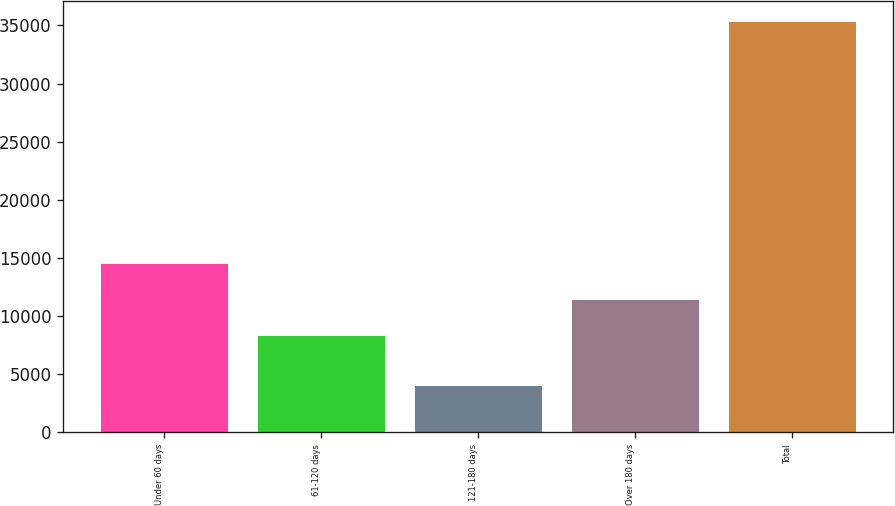<chart> <loc_0><loc_0><loc_500><loc_500><bar_chart><fcel>Under 60 days<fcel>61-120 days<fcel>121-180 days<fcel>Over 180 days<fcel>Total<nl><fcel>14523.4<fcel>8254<fcel>3975<fcel>11388.7<fcel>35322<nl></chart> 